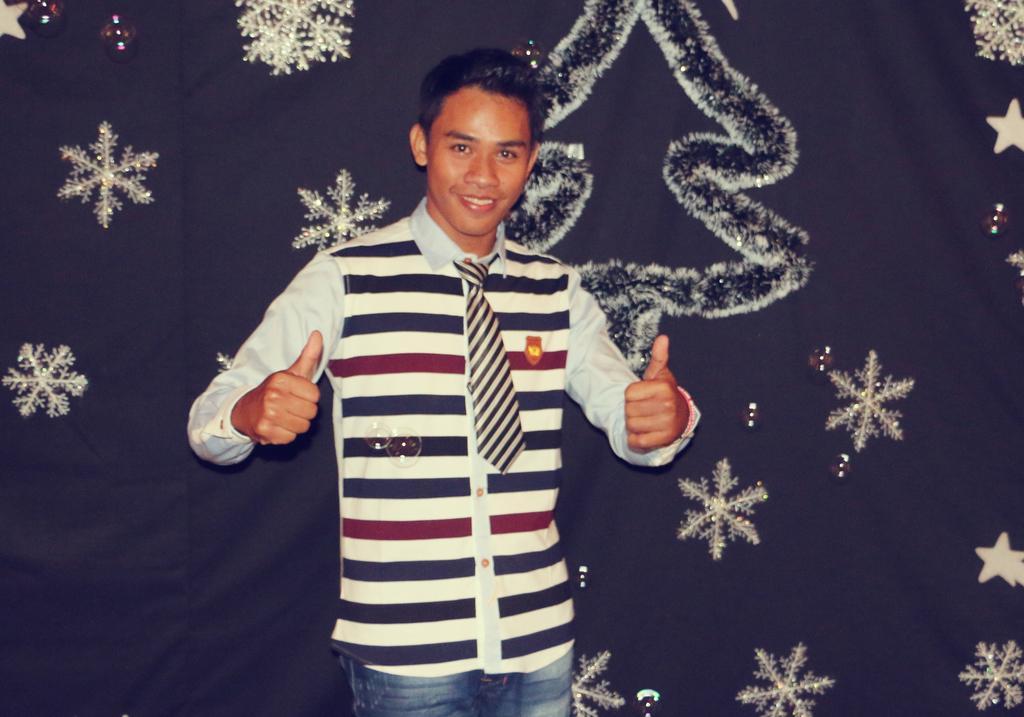How would you summarize this image in a sentence or two? In this image there is a boy in the middle who is showing his thumbs up. In the background there is a curtain on which there is some design. On the right side there are stars on the curtain. Beside the stars there is a Christmas tree. 